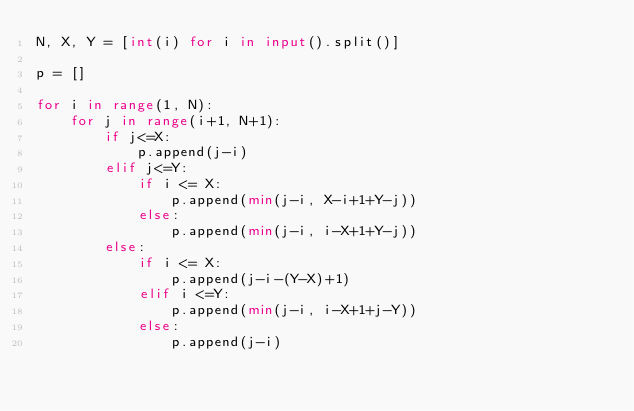Convert code to text. <code><loc_0><loc_0><loc_500><loc_500><_Python_>N, X, Y = [int(i) for i in input().split()]

p = []

for i in range(1, N):
    for j in range(i+1, N+1):
        if j<=X:
            p.append(j-i)
        elif j<=Y:
            if i <= X:
                p.append(min(j-i, X-i+1+Y-j))
            else:
                p.append(min(j-i, i-X+1+Y-j))
        else:
            if i <= X:
                p.append(j-i-(Y-X)+1)
            elif i <=Y:
                p.append(min(j-i, i-X+1+j-Y))
            else:
                p.append(j-i)</code> 